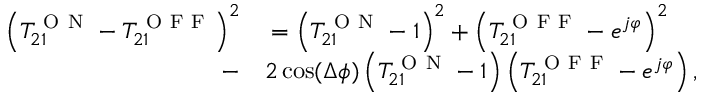<formula> <loc_0><loc_0><loc_500><loc_500>\begin{array} { r l } { \left ( T _ { 2 1 } ^ { O N } - T _ { 2 1 } ^ { O F F } \right ) ^ { 2 } } & = \left ( T _ { 2 1 } ^ { O N } - 1 \right ) ^ { 2 } + \left ( T _ { 2 1 } ^ { O F F } - e ^ { j \varphi } \right ) ^ { 2 } } \\ { - } & 2 \cos ( \Delta \phi ) \left ( T _ { 2 1 } ^ { O N } - 1 \right ) \left ( T _ { 2 1 } ^ { O F F } - e ^ { j \varphi } \right ) , } \end{array}</formula> 